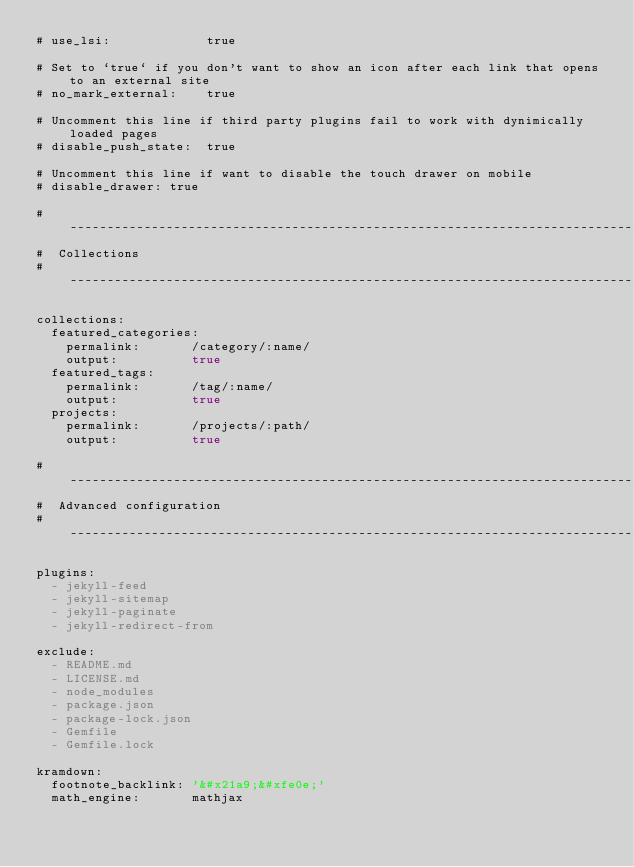Convert code to text. <code><loc_0><loc_0><loc_500><loc_500><_YAML_># use_lsi:             true

# Set to `true` if you don't want to show an icon after each link that opens to an external site
# no_mark_external:    true

# Uncomment this line if third party plugins fail to work with dynimically loaded pages
# disable_push_state:  true

# Uncomment this line if want to disable the touch drawer on mobile
# disable_drawer: true

# -----------------------------------------------------------------------------
#  Collections
# -----------------------------------------------------------------------------

collections:
  featured_categories:
    permalink:       /category/:name/
    output:          true
  featured_tags:
    permalink:       /tag/:name/
    output:          true
  projects:
    permalink:       /projects/:path/
    output:          true

# -----------------------------------------------------------------------------
#  Advanced configuration
# -----------------------------------------------------------------------------

plugins:
  - jekyll-feed
  - jekyll-sitemap
  - jekyll-paginate
  - jekyll-redirect-from

exclude:
  - README.md
  - LICENSE.md
  - node_modules
  - package.json
  - package-lock.json
  - Gemfile
  - Gemfile.lock

kramdown:
  footnote_backlink: '&#x21a9;&#xfe0e;'
  math_engine:       mathjax</code> 